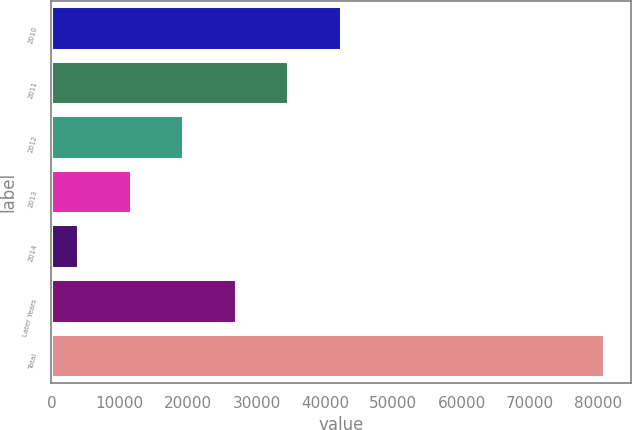Convert chart to OTSL. <chart><loc_0><loc_0><loc_500><loc_500><bar_chart><fcel>2010<fcel>2011<fcel>2012<fcel>2013<fcel>2014<fcel>Later Years<fcel>Total<nl><fcel>42329<fcel>34638.4<fcel>19257.2<fcel>11566.6<fcel>3876<fcel>26947.8<fcel>80782<nl></chart> 